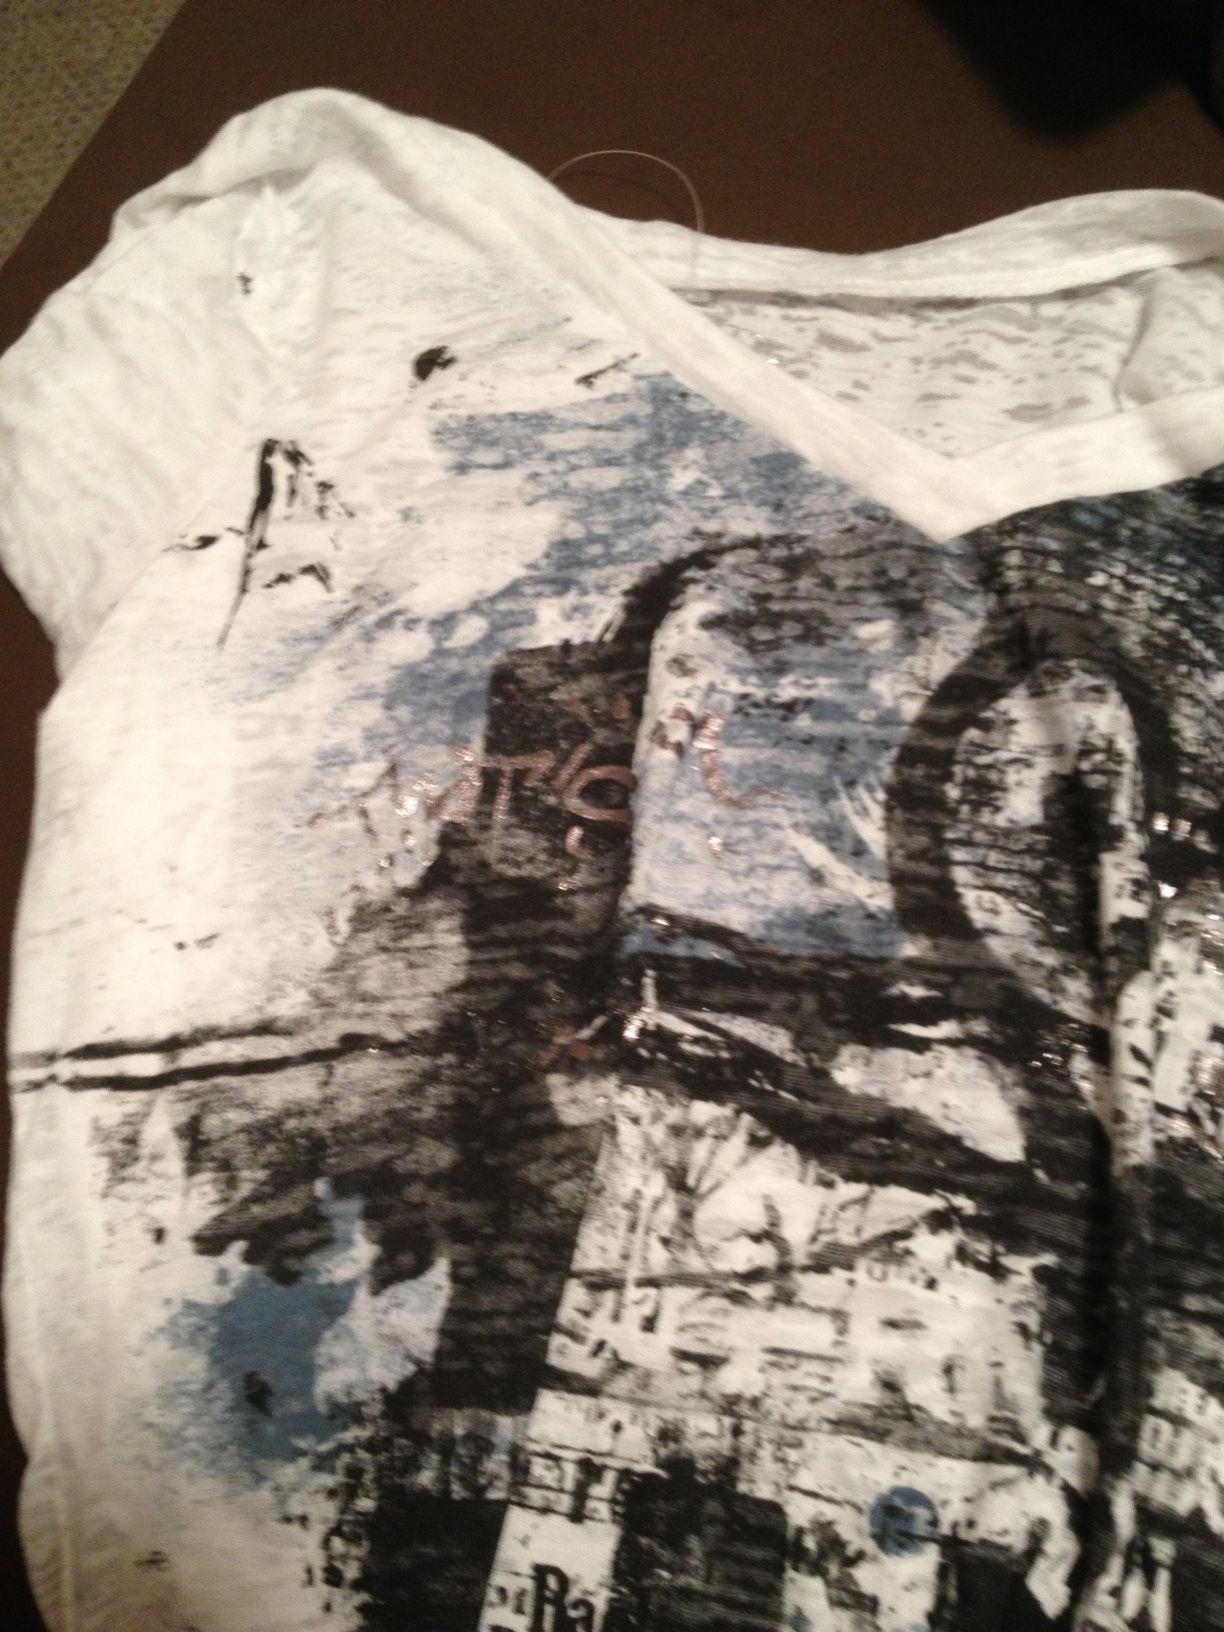Could this shirt be part of a new fashion trend? If so, describe the trend. Yes, this shirt could be part of a new fashion trend focused on 'Art-Inspired Wearables.' This trend would blend fashion with abstract art, featuring designs that mimic brush strokes, splatters, and mixed media textures. The pieces would boast a variety of colors and patterns, creating visually compelling and conversation-starting garments. The idea is to wear art and express individuality through fashion that breaks away from traditional prints and patterns, embracing a more avant-garde approach. 